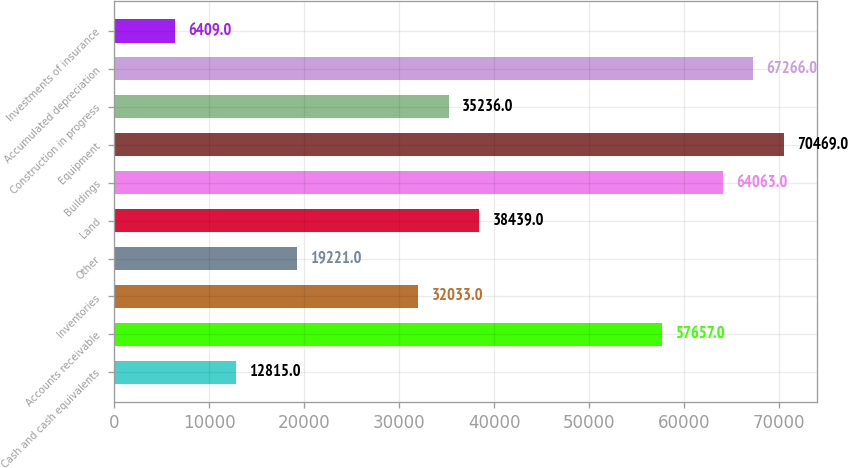Convert chart to OTSL. <chart><loc_0><loc_0><loc_500><loc_500><bar_chart><fcel>Cash and cash equivalents<fcel>Accounts receivable<fcel>Inventories<fcel>Other<fcel>Land<fcel>Buildings<fcel>Equipment<fcel>Construction in progress<fcel>Accumulated depreciation<fcel>Investments of insurance<nl><fcel>12815<fcel>57657<fcel>32033<fcel>19221<fcel>38439<fcel>64063<fcel>70469<fcel>35236<fcel>67266<fcel>6409<nl></chart> 